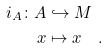<formula> <loc_0><loc_0><loc_500><loc_500>i _ { A } \colon A & \hookrightarrow M \\ x & \mapsto x \quad .</formula> 